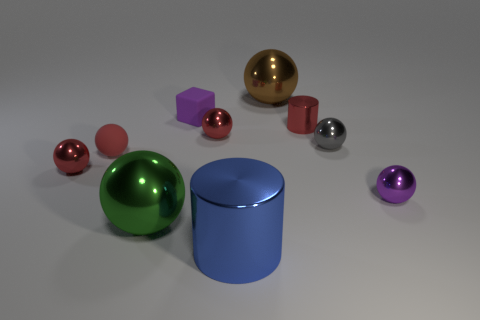Subtract all purple blocks. How many red spheres are left? 3 Subtract all tiny red balls. How many balls are left? 4 Subtract all green spheres. How many spheres are left? 6 Subtract all green spheres. Subtract all gray cylinders. How many spheres are left? 6 Subtract all blocks. How many objects are left? 9 Add 5 brown matte objects. How many brown matte objects exist? 5 Subtract 1 brown balls. How many objects are left? 9 Subtract all tiny red shiny things. Subtract all tiny red metal objects. How many objects are left? 4 Add 3 small red rubber things. How many small red rubber things are left? 4 